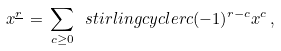Convert formula to latex. <formula><loc_0><loc_0><loc_500><loc_500>x ^ { \underline { r } } \, = \, \sum _ { c \geq 0 } \ s t i r l i n g c y c l e { r } { c } ( - 1 ) ^ { r - c } x ^ { c } \, ,</formula> 